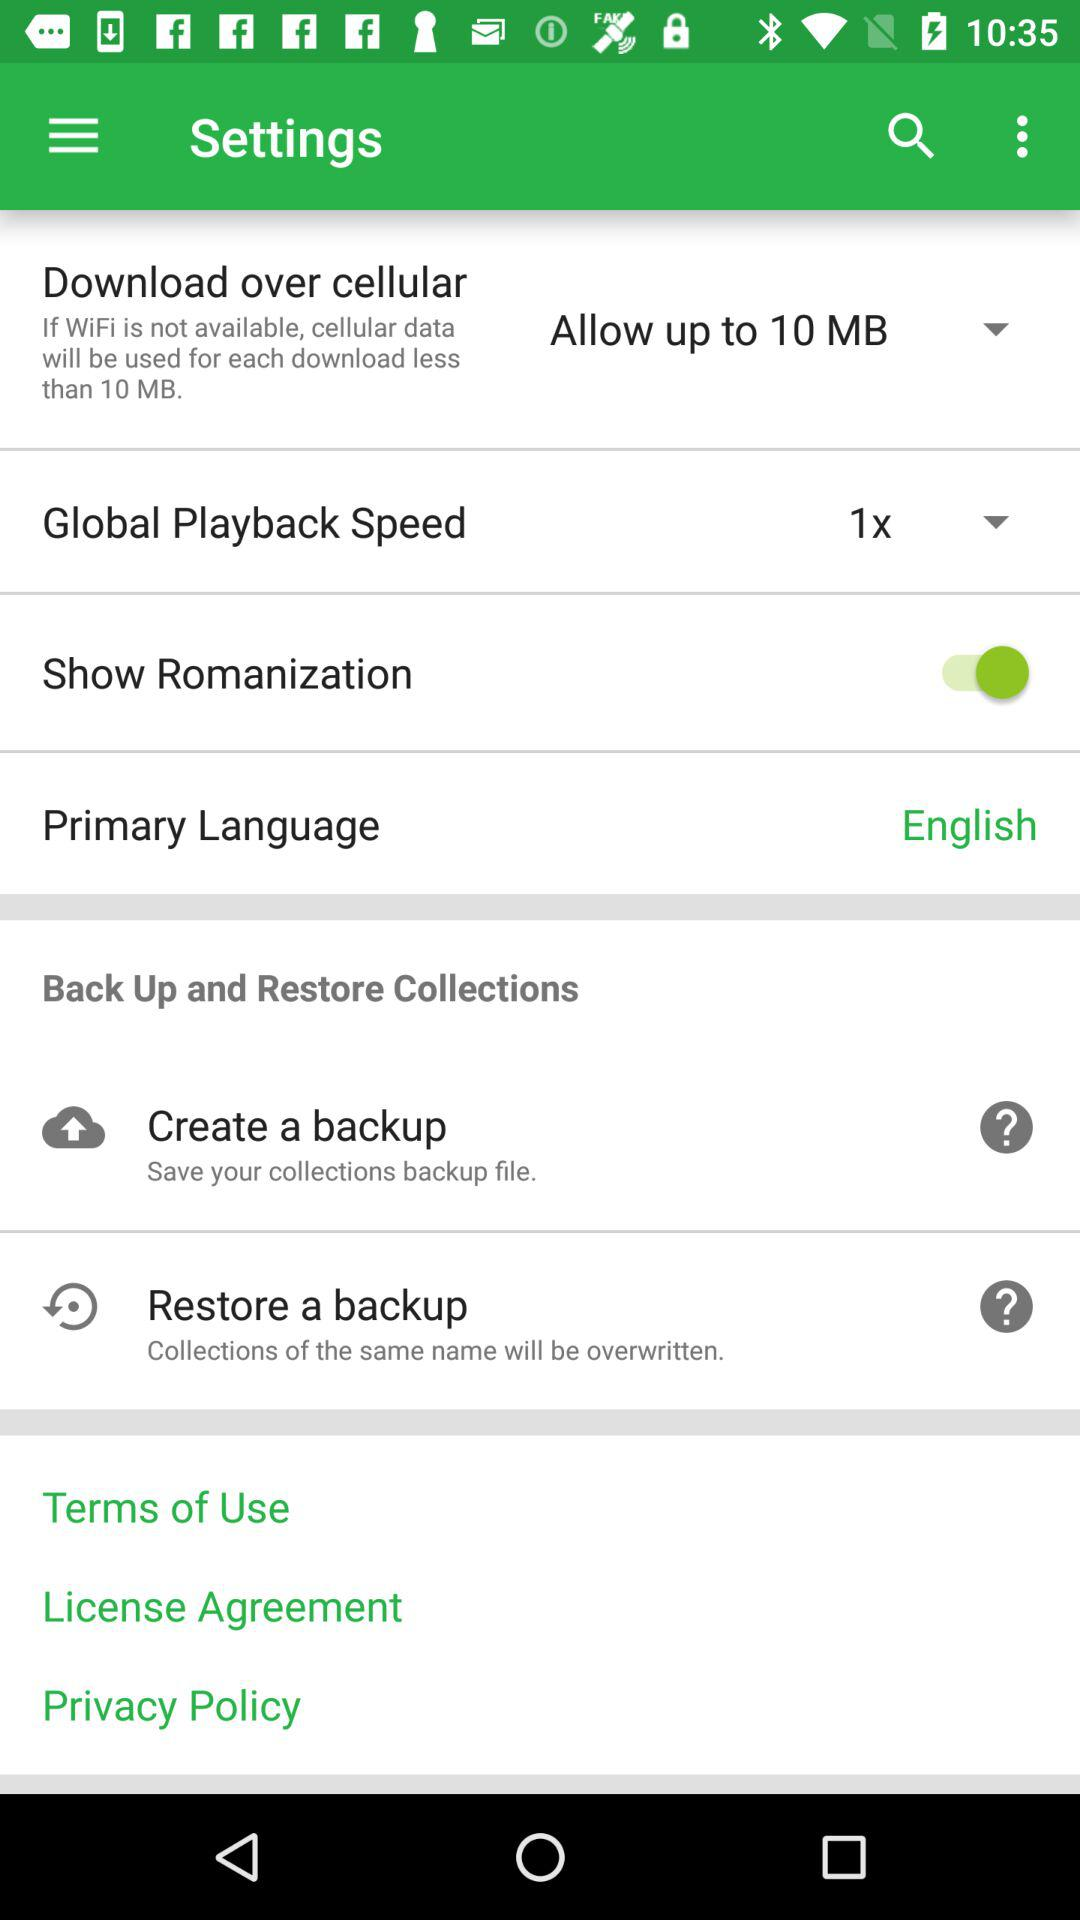What is the maximum limit for downloading over cellular? The maximum limit is 10 MB. 